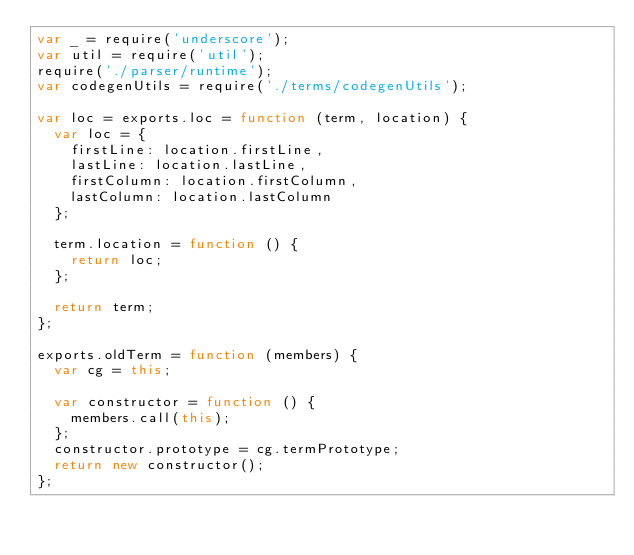<code> <loc_0><loc_0><loc_500><loc_500><_JavaScript_>var _ = require('underscore');
var util = require('util');
require('./parser/runtime');
var codegenUtils = require('./terms/codegenUtils');

var loc = exports.loc = function (term, location) {
  var loc = {
    firstLine: location.firstLine,
    lastLine: location.lastLine,
    firstColumn: location.firstColumn,
    lastColumn: location.lastColumn
  };

  term.location = function () {
    return loc;
  };
  
  return term;
};

exports.oldTerm = function (members) {
  var cg = this;
  
  var constructor = function () {
    members.call(this);
  };
  constructor.prototype = cg.termPrototype;
  return new constructor();
};
</code> 